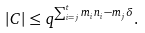Convert formula to latex. <formula><loc_0><loc_0><loc_500><loc_500>| C | \leq q ^ { \sum _ { i = j } ^ { t } m _ { i } n _ { i } - m _ { j } \delta } .</formula> 